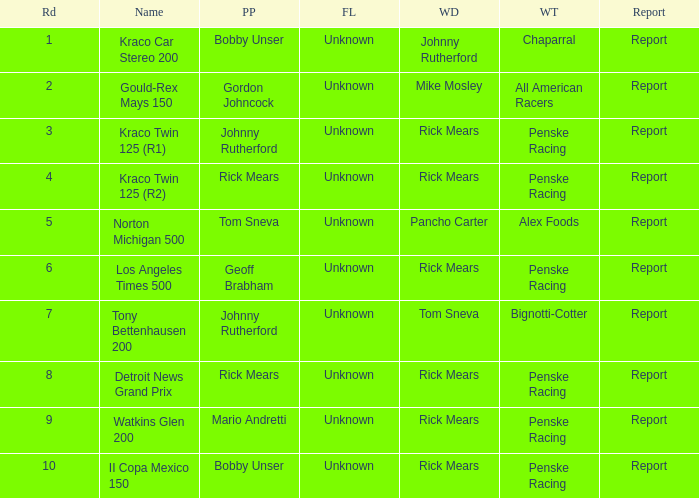What are the races that johnny rutherford has won? Kraco Car Stereo 200. 